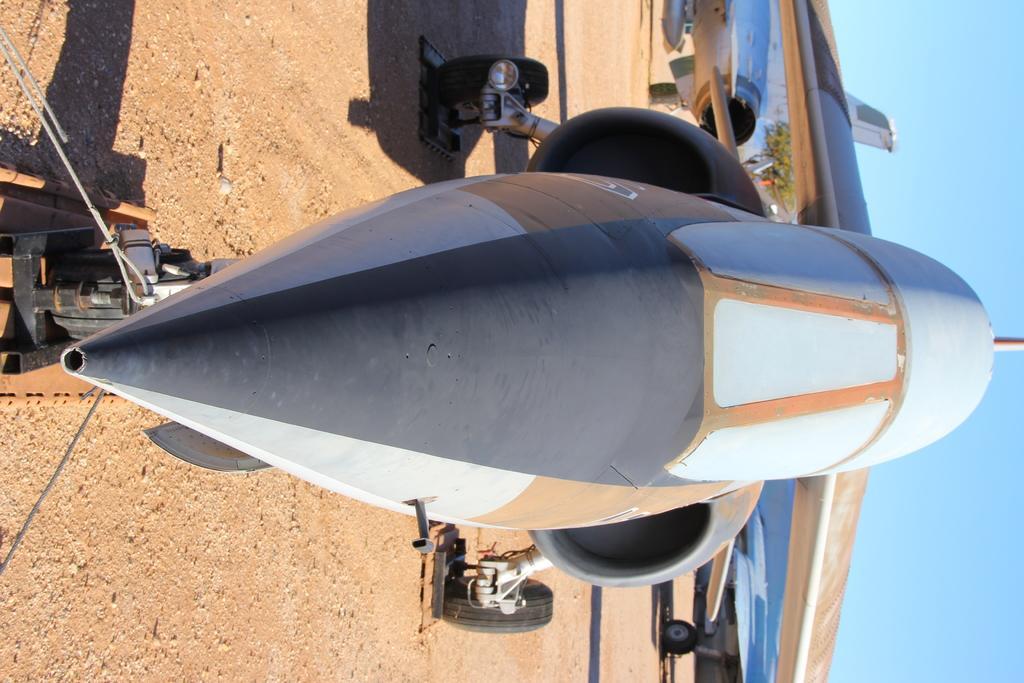Please provide a concise description of this image. In this picture we can see airplanes on the ground and in the background we can see a tree, sky. 